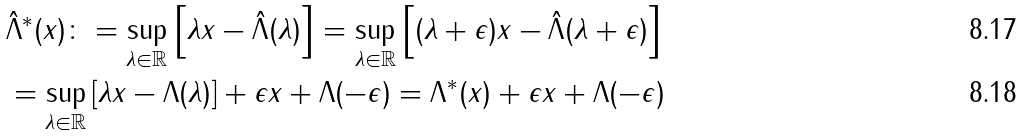Convert formula to latex. <formula><loc_0><loc_0><loc_500><loc_500>& \hat { \Lambda } ^ { * } ( x ) \colon = \sup _ { \lambda \in \mathbb { R } } \left [ \lambda x - \hat { \Lambda } ( \lambda ) \right ] = \sup _ { \lambda \in \mathbb { R } } \left [ ( \lambda + \epsilon ) x - \hat { \Lambda } ( \lambda + \epsilon ) \right ] \\ & = \sup _ { \lambda \in \mathbb { R } } \left [ \lambda x - \Lambda ( \lambda ) \right ] + \epsilon x + \Lambda ( - \epsilon ) = \Lambda ^ { * } ( x ) + \epsilon x + \Lambda ( - \epsilon )</formula> 